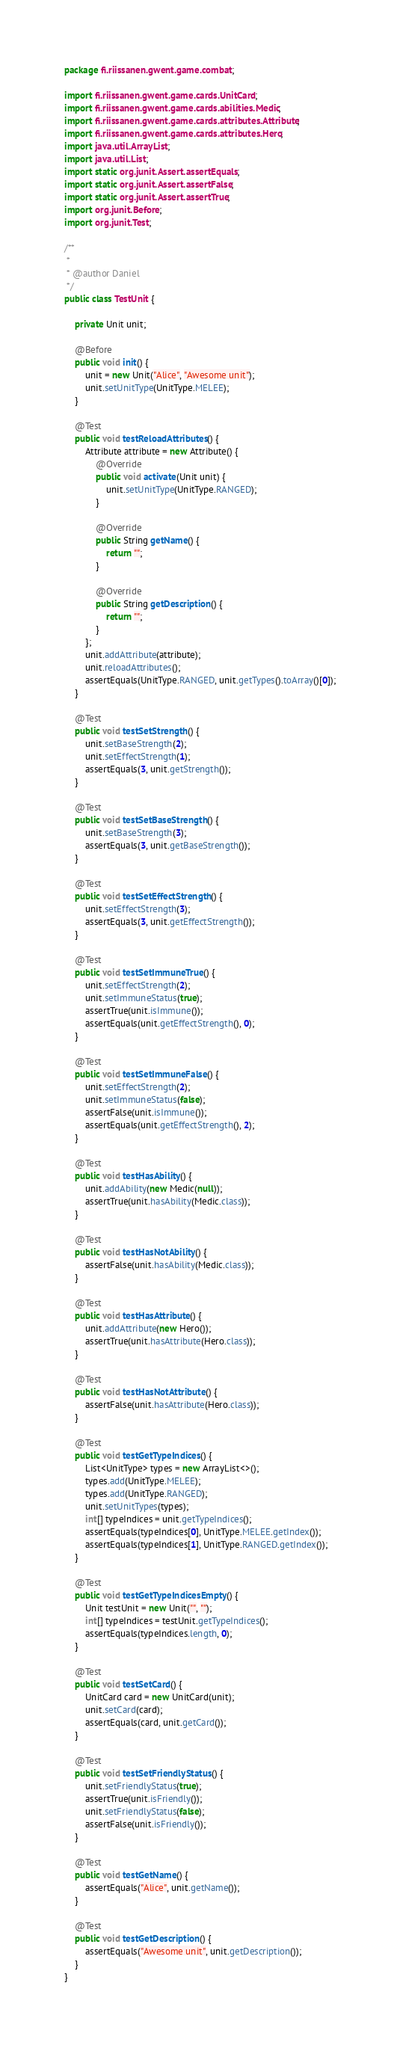Convert code to text. <code><loc_0><loc_0><loc_500><loc_500><_Java_>package fi.riissanen.gwent.game.combat;

import fi.riissanen.gwent.game.cards.UnitCard;
import fi.riissanen.gwent.game.cards.abilities.Medic;
import fi.riissanen.gwent.game.cards.attributes.Attribute;
import fi.riissanen.gwent.game.cards.attributes.Hero;
import java.util.ArrayList;
import java.util.List;
import static org.junit.Assert.assertEquals;
import static org.junit.Assert.assertFalse;
import static org.junit.Assert.assertTrue;
import org.junit.Before;
import org.junit.Test;

/**
 *
 * @author Daniel
 */
public class TestUnit {

    private Unit unit;
    
    @Before
    public void init() {
        unit = new Unit("Alice", "Awesome unit");
        unit.setUnitType(UnitType.MELEE);
    }
    
    @Test
    public void testReloadAttributes() {
        Attribute attribute = new Attribute() {
            @Override
            public void activate(Unit unit) {
                unit.setUnitType(UnitType.RANGED);
            }

            @Override
            public String getName() {
                return "";
            }

            @Override
            public String getDescription() {
                return "";
            }
        };
        unit.addAttribute(attribute);
        unit.reloadAttributes();
        assertEquals(UnitType.RANGED, unit.getTypes().toArray()[0]);
    }
    
    @Test
    public void testSetStrength() {
        unit.setBaseStrength(2);
        unit.setEffectStrength(1);
        assertEquals(3, unit.getStrength());
    }
        
    @Test
    public void testSetBaseStrength() {
        unit.setBaseStrength(3);
        assertEquals(3, unit.getBaseStrength());
    }
    
    @Test
    public void testSetEffectStrength() {
        unit.setEffectStrength(3);
        assertEquals(3, unit.getEffectStrength());
    }
    
    @Test
    public void testSetImmuneTrue() {
        unit.setEffectStrength(2);
        unit.setImmuneStatus(true);
        assertTrue(unit.isImmune());
        assertEquals(unit.getEffectStrength(), 0);
    }
    
    @Test
    public void testSetImmuneFalse() {
        unit.setEffectStrength(2);
        unit.setImmuneStatus(false);
        assertFalse(unit.isImmune());
        assertEquals(unit.getEffectStrength(), 2);
    }
    
    @Test
    public void testHasAbility() {
        unit.addAbility(new Medic(null));
        assertTrue(unit.hasAbility(Medic.class));
    }
    
    @Test
    public void testHasNotAbility() {
        assertFalse(unit.hasAbility(Medic.class));
    }
    
    @Test
    public void testHasAttribute() {
        unit.addAttribute(new Hero());
        assertTrue(unit.hasAttribute(Hero.class));
    }
    
    @Test
    public void testHasNotAttribute() {
        assertFalse(unit.hasAttribute(Hero.class));
    }
    
    @Test
    public void testGetTypeIndices() {
        List<UnitType> types = new ArrayList<>();
        types.add(UnitType.MELEE);
        types.add(UnitType.RANGED);
        unit.setUnitTypes(types);
        int[] typeIndices = unit.getTypeIndices();
        assertEquals(typeIndices[0], UnitType.MELEE.getIndex());
        assertEquals(typeIndices[1], UnitType.RANGED.getIndex());
    }
    
    @Test
    public void testGetTypeIndicesEmpty() {
        Unit testUnit = new Unit("", "");
        int[] typeIndices = testUnit.getTypeIndices();
        assertEquals(typeIndices.length, 0);
    }
    
    @Test
    public void testSetCard() {
        UnitCard card = new UnitCard(unit);
        unit.setCard(card);
        assertEquals(card, unit.getCard());
    }
    
    @Test
    public void testSetFriendlyStatus() {
        unit.setFriendlyStatus(true);
        assertTrue(unit.isFriendly());
        unit.setFriendlyStatus(false);
        assertFalse(unit.isFriendly());
    }
    
    @Test
    public void testGetName() {
        assertEquals("Alice", unit.getName());
    }
    
    @Test
    public void testGetDescription() {
        assertEquals("Awesome unit", unit.getDescription());
    }
}
</code> 